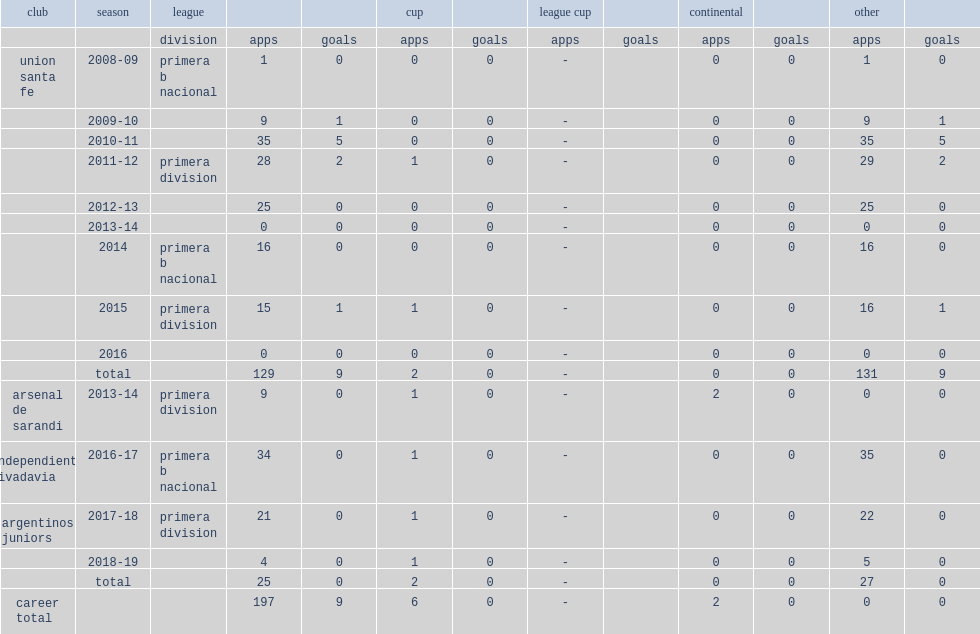Parse the full table. {'header': ['club', 'season', 'league', '', '', 'cup', '', 'league cup', '', 'continental', '', 'other', ''], 'rows': [['', '', 'division', 'apps', 'goals', 'apps', 'goals', 'apps', 'goals', 'apps', 'goals', 'apps', 'goals'], ['union santa fe', '2008-09', 'primera b nacional', '1', '0', '0', '0', '-', '', '0', '0', '1', '0'], ['', '2009-10', '', '9', '1', '0', '0', '-', '', '0', '0', '9', '1'], ['', '2010-11', '', '35', '5', '0', '0', '-', '', '0', '0', '35', '5'], ['', '2011-12', 'primera division', '28', '2', '1', '0', '-', '', '0', '0', '29', '2'], ['', '2012-13', '', '25', '0', '0', '0', '-', '', '0', '0', '25', '0'], ['', '2013-14', '', '0', '0', '0', '0', '-', '', '0', '0', '0', '0'], ['', '2014', 'primera b nacional', '16', '0', '0', '0', '-', '', '0', '0', '16', '0'], ['', '2015', 'primera division', '15', '1', '1', '0', '-', '', '0', '0', '16', '1'], ['', '2016', '', '0', '0', '0', '0', '-', '', '0', '0', '0', '0'], ['', 'total', '', '129', '9', '2', '0', '-', '', '0', '0', '131', '9'], ['arsenal de sarandi', '2013-14', 'primera division', '9', '0', '1', '0', '-', '', '2', '0', '0', '0'], ['independiente rivadavia', '2016-17', 'primera b nacional', '34', '0', '1', '0', '-', '', '0', '0', '35', '0'], ['argentinos juniors', '2017-18', 'primera division', '21', '0', '1', '0', '-', '', '0', '0', '22', '0'], ['', '2018-19', '', '4', '0', '1', '0', '-', '', '0', '0', '5', '0'], ['', 'total', '', '25', '0', '2', '0', '-', '', '0', '0', '27', '0'], ['career total', '', '', '197', '9', '6', '0', '-', '', '2', '0', '0', '0']]} Which league was union santa fe montero's first career club, participating in the 2008-09 season? Primera b nacional. 